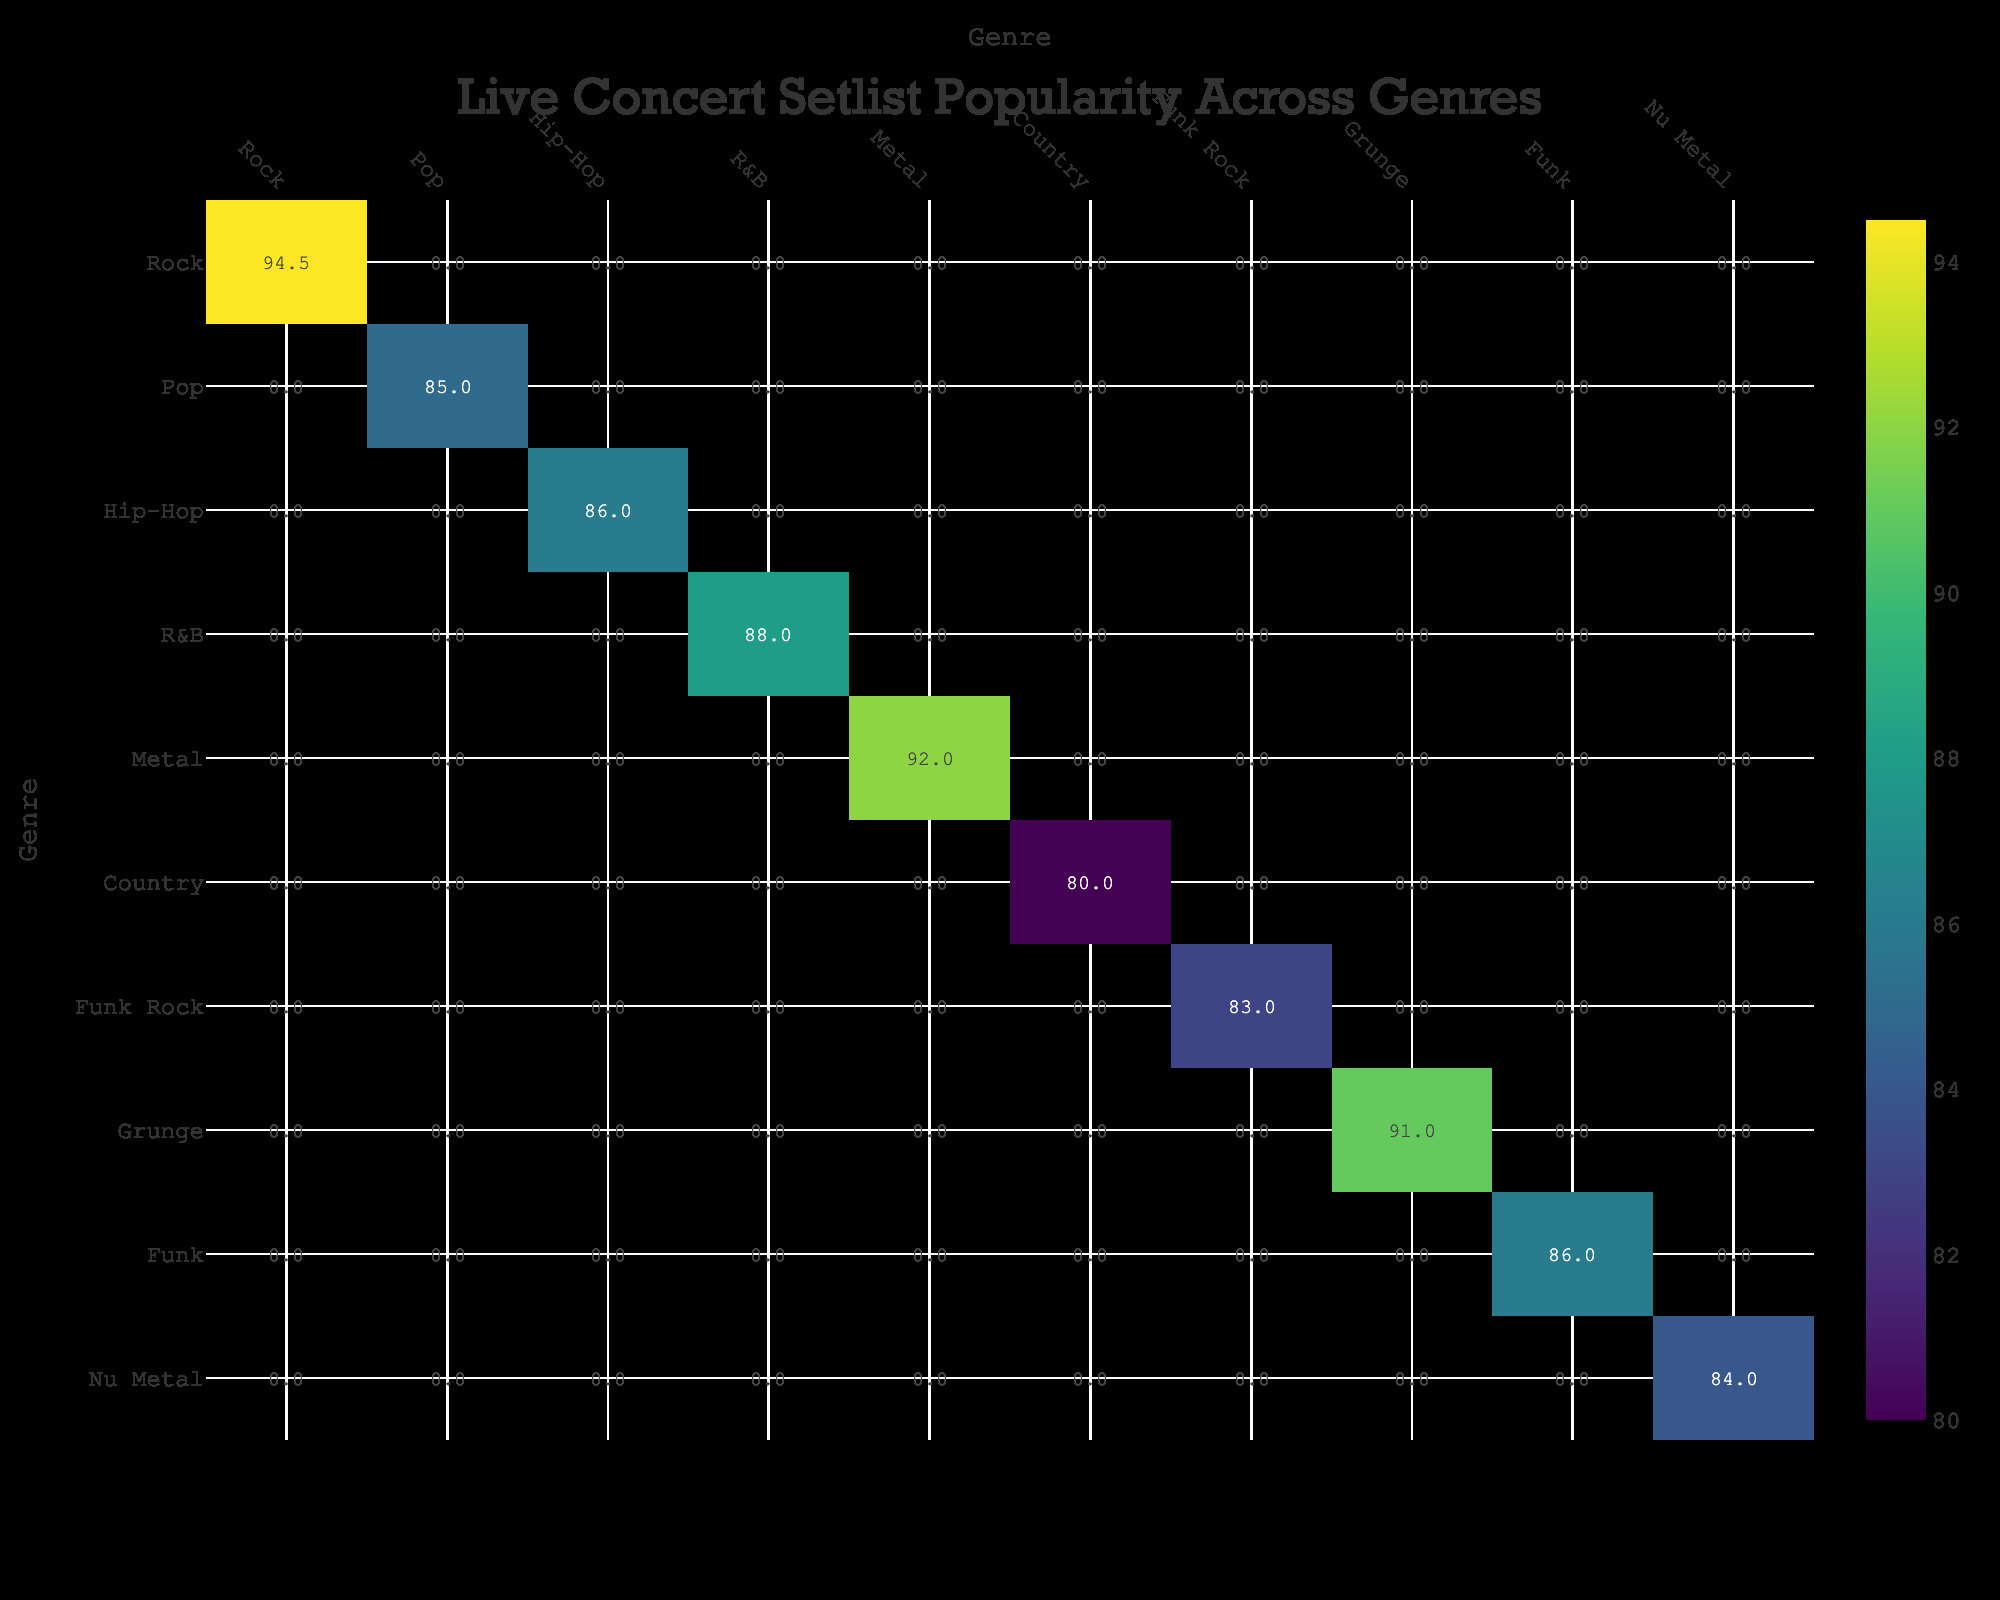What is the setlist popularity for Pop genre? The Pop genre includes artists like Beyoncé, Adele, Billie Eilish, and Ed Sheeran. Their setlist popularities are 90, 89, 79, and 82 respectively. To find the setlist popularity for the Pop genre, I will look at the value corresponding to Pop in the table, which is the average calculated from these artists, resulting in an average of 85.
Answer: 85 Which genre has the highest setlist popularity? To find the genre with the highest setlist popularity, I will review all the values in the table. The highest value is 95 for the Rock genre, performed by Queen.
Answer: Rock Is the setlist popularity for Hip-Hop greater than that for R&B? The setlist popularity for Hip-Hop is represented by Kendrick Lamar and Eminem, with scores of 85 and 87 respectively, yielding an average of 86. The R&B genre, represented by The Weeknd, has a setlist popularity of 88. Since 86 (Hip-Hop) is less than 88 (R&B), the statement is false.
Answer: No What is the average setlist popularity for genres that include 'Rock' in their name? The Rock genre has a popularity of 95 (Queen) and AC/DC (also Rock) has a popularity of 94. To find the average, sum the values (95 + 94) and divide by 2, which equals 94.5.
Answer: 94.5 Which genre has a setlist popularity less than 80? The only genre with a setlist popularity less than 80 is Country, which has a popularity of 80 exactly. Therefore, it does not have a popularity less than 80.
Answer: No How many genres have a setlist popularity of 90 or higher? By reviewing the table, the genres with popularity scores of 90 or higher are Rock (95), Pop (90), Metal (92), and Grunge (91), totaling four genres.
Answer: 4 If you combine the popularity of Funk and Funk Rock genres, what would be the total? The Funk genre represented by Bruno Mars has a popularity of 86, and the Funk Rock genre represented by Red Hot Chili Peppers has a popularity of 83. The total is calculated by adding these two values together: 86 + 83 = 169.
Answer: 169 Are there more artists represented in the Pop genre than in the Rock genre? The Pop genre includes four artists: Beyoncé, Adele, Billie Eilish, and Ed Sheeran, while the Rock genre has two artists: Queen and AC/DC. Therefore, there are more artists in the Pop genre.
Answer: Yes 